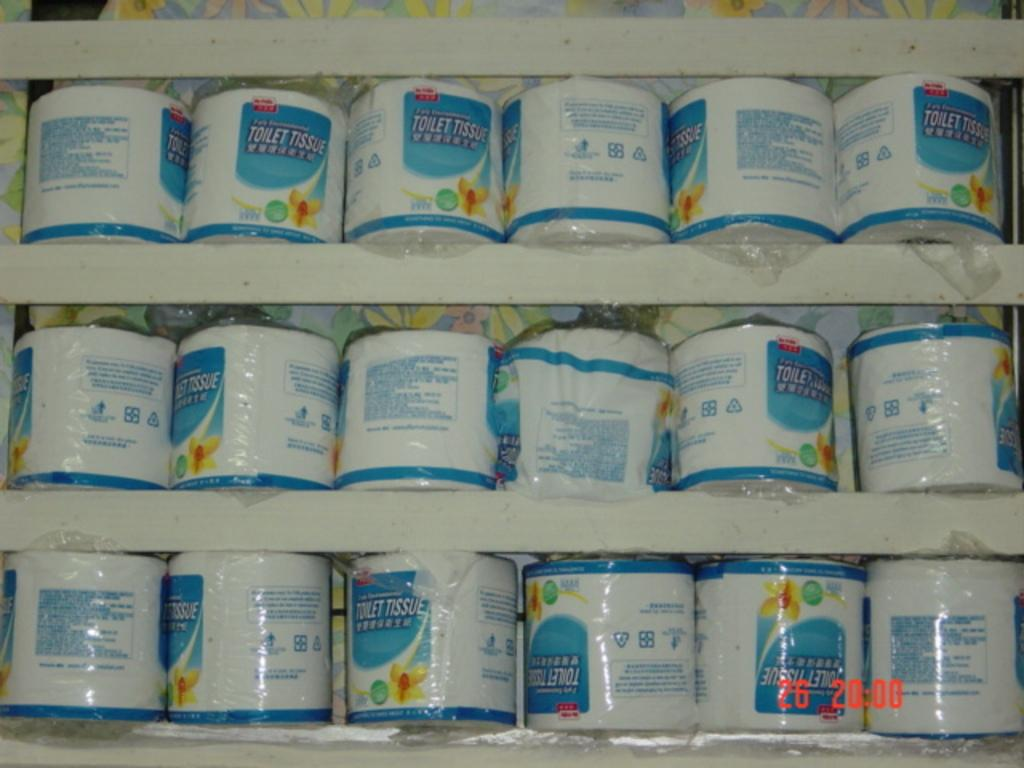<image>
Present a compact description of the photo's key features. A selection of toilet tissue that was photographed at 20:00. 